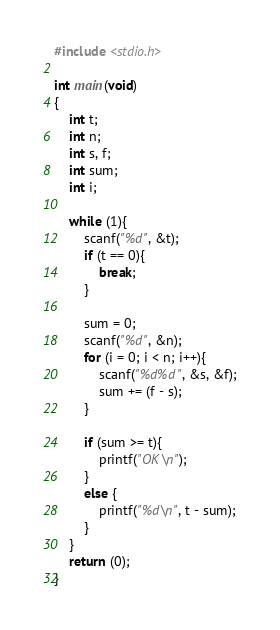<code> <loc_0><loc_0><loc_500><loc_500><_C_>#include <stdio.h>

int main(void)
{
    int t;
    int n;
    int s, f;
    int sum;
    int i;
    
    while (1){
        scanf("%d", &t);
        if (t == 0){
            break;
        }
        
        sum = 0;
        scanf("%d", &n);
        for (i = 0; i < n; i++){
            scanf("%d%d", &s, &f);
            sum += (f - s);
        }
        
        if (sum >= t){
            printf("OK\n");
        }
        else {
            printf("%d\n", t - sum);
        }
    }
    return (0);
}</code> 